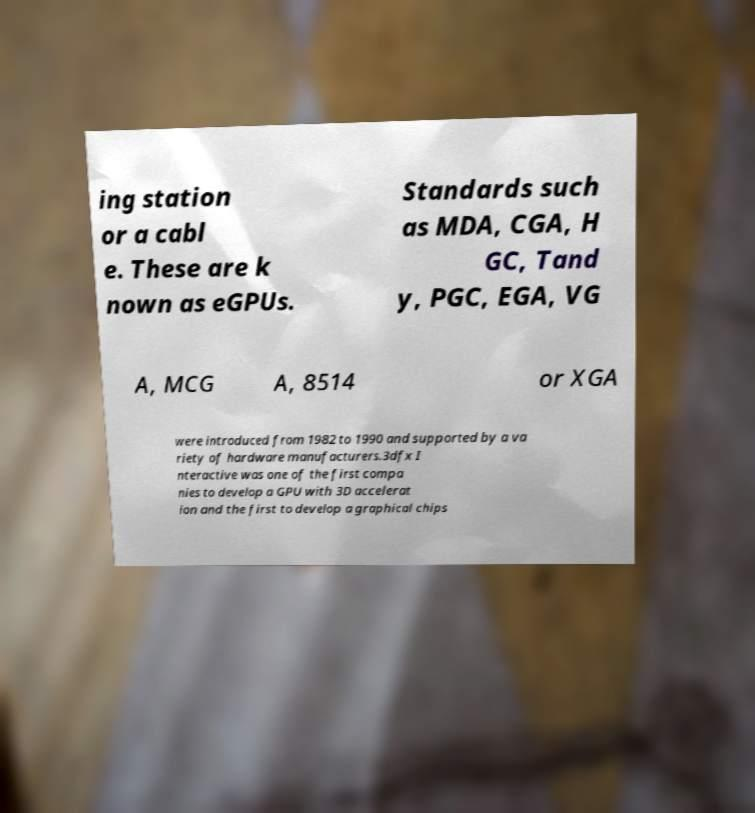I need the written content from this picture converted into text. Can you do that? ing station or a cabl e. These are k nown as eGPUs. Standards such as MDA, CGA, H GC, Tand y, PGC, EGA, VG A, MCG A, 8514 or XGA were introduced from 1982 to 1990 and supported by a va riety of hardware manufacturers.3dfx I nteractive was one of the first compa nies to develop a GPU with 3D accelerat ion and the first to develop a graphical chips 